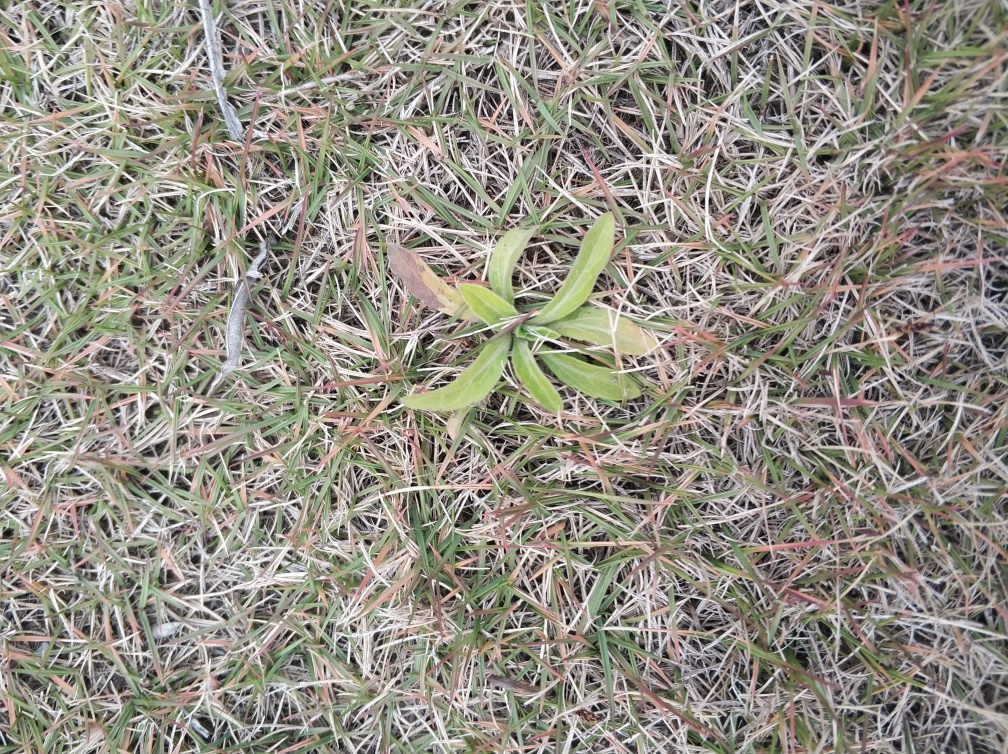What time of year does this image suggest it might be? The grass in this image appears to be in a transitional state, with both green and brown patches, which could indicate either the approach of spring or the onset of fall, when vegetation is responding to changes in temperature and sunlight.  Could you tell me more about the vegetation in the picture? Certainly! The image features grass with varying colors and conditions, suggesting a natural lawn or field undergoing seasonal changes. There's a cluster of green grass in the center, which stands out vivaciously against the duller, dehydrated surrounding blades that might have succumbed to colder temperatures or less water. 